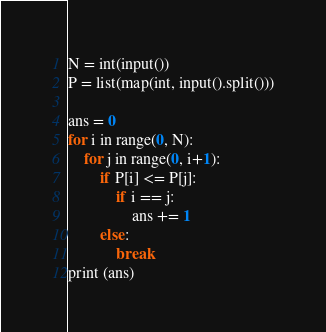Convert code to text. <code><loc_0><loc_0><loc_500><loc_500><_Python_>N = int(input())
P = list(map(int, input().split()))

ans = 0
for i in range(0, N):
    for j in range(0, i+1):
        if P[i] <= P[j]:
            if i == j:
                ans += 1
        else: 
            break
print (ans)</code> 